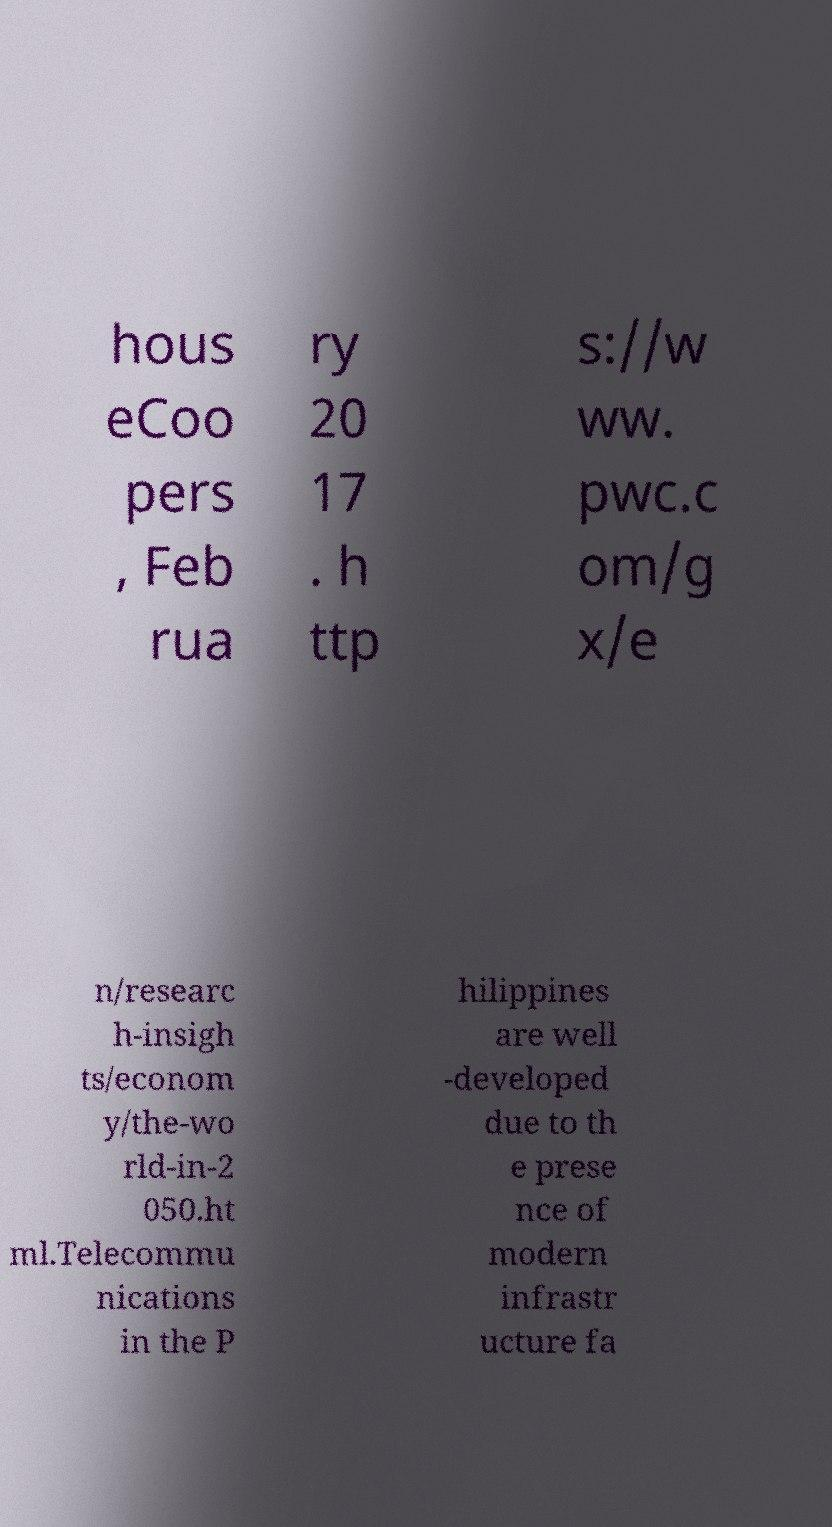For documentation purposes, I need the text within this image transcribed. Could you provide that? hous eCoo pers , Feb rua ry 20 17 . h ttp s://w ww. pwc.c om/g x/e n/researc h-insigh ts/econom y/the-wo rld-in-2 050.ht ml.Telecommu nications in the P hilippines are well -developed due to th e prese nce of modern infrastr ucture fa 